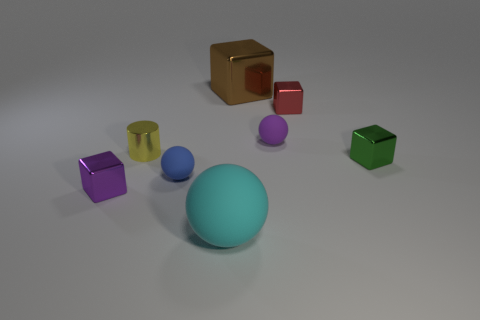Subtract all small spheres. How many spheres are left? 1 Add 1 big cyan metallic things. How many objects exist? 9 Subtract all blue balls. How many balls are left? 2 Subtract 1 cylinders. How many cylinders are left? 0 Subtract 0 yellow cubes. How many objects are left? 8 Subtract all balls. How many objects are left? 5 Subtract all yellow cubes. Subtract all brown cylinders. How many cubes are left? 4 Subtract all yellow spheres. How many green blocks are left? 1 Subtract all cyan blocks. Subtract all red metal blocks. How many objects are left? 7 Add 1 large brown metallic blocks. How many large brown metallic blocks are left? 2 